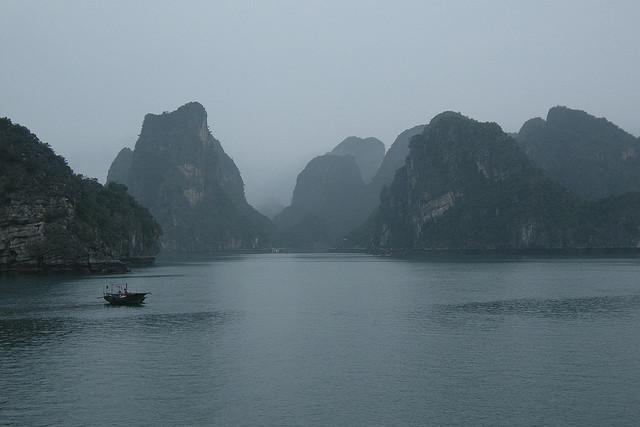How many boats on the water?
Quick response, please. 1. What is in the water?
Write a very short answer. Boat. Can you swim here?
Be succinct. Yes. How is the visibility?
Give a very brief answer. Foggy. Is there snow on the mountains?
Short answer required. No. Is this a sunny day?
Write a very short answer. No. 